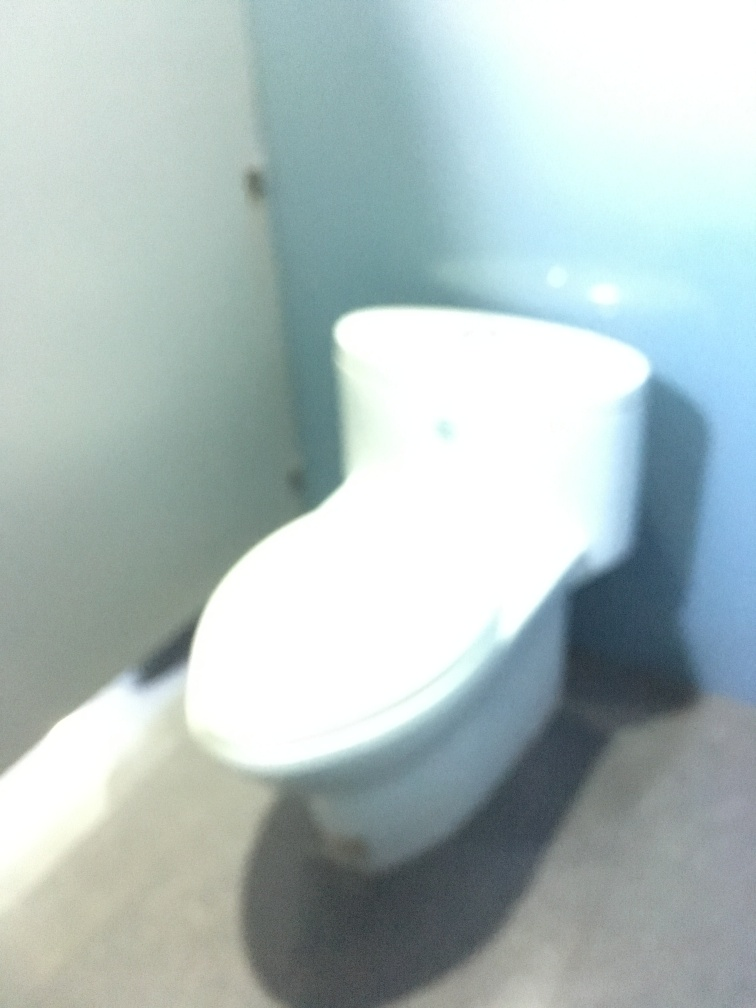Is the quality of the photo very poor?
A. Yes
B. No
Answer with the option's letter from the given choices directly.
 A. 